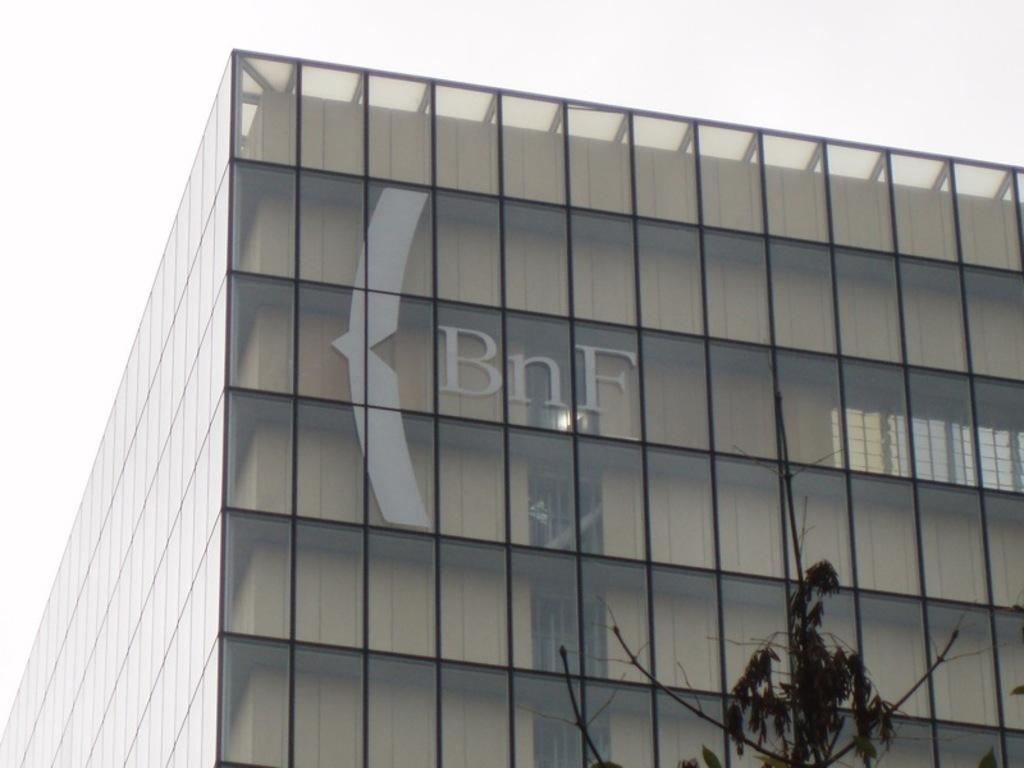What is the main subject in the center of the image? There is a building in the center of the image. What can be seen at the bottom of the image? There is a tree at the bottom of the image. What is visible in the background of the image? The sky is visible in the background of the image. Where is the band playing in the image? There is no band present in the image. What type of shop can be seen in the image? There is no shop present in the image. 